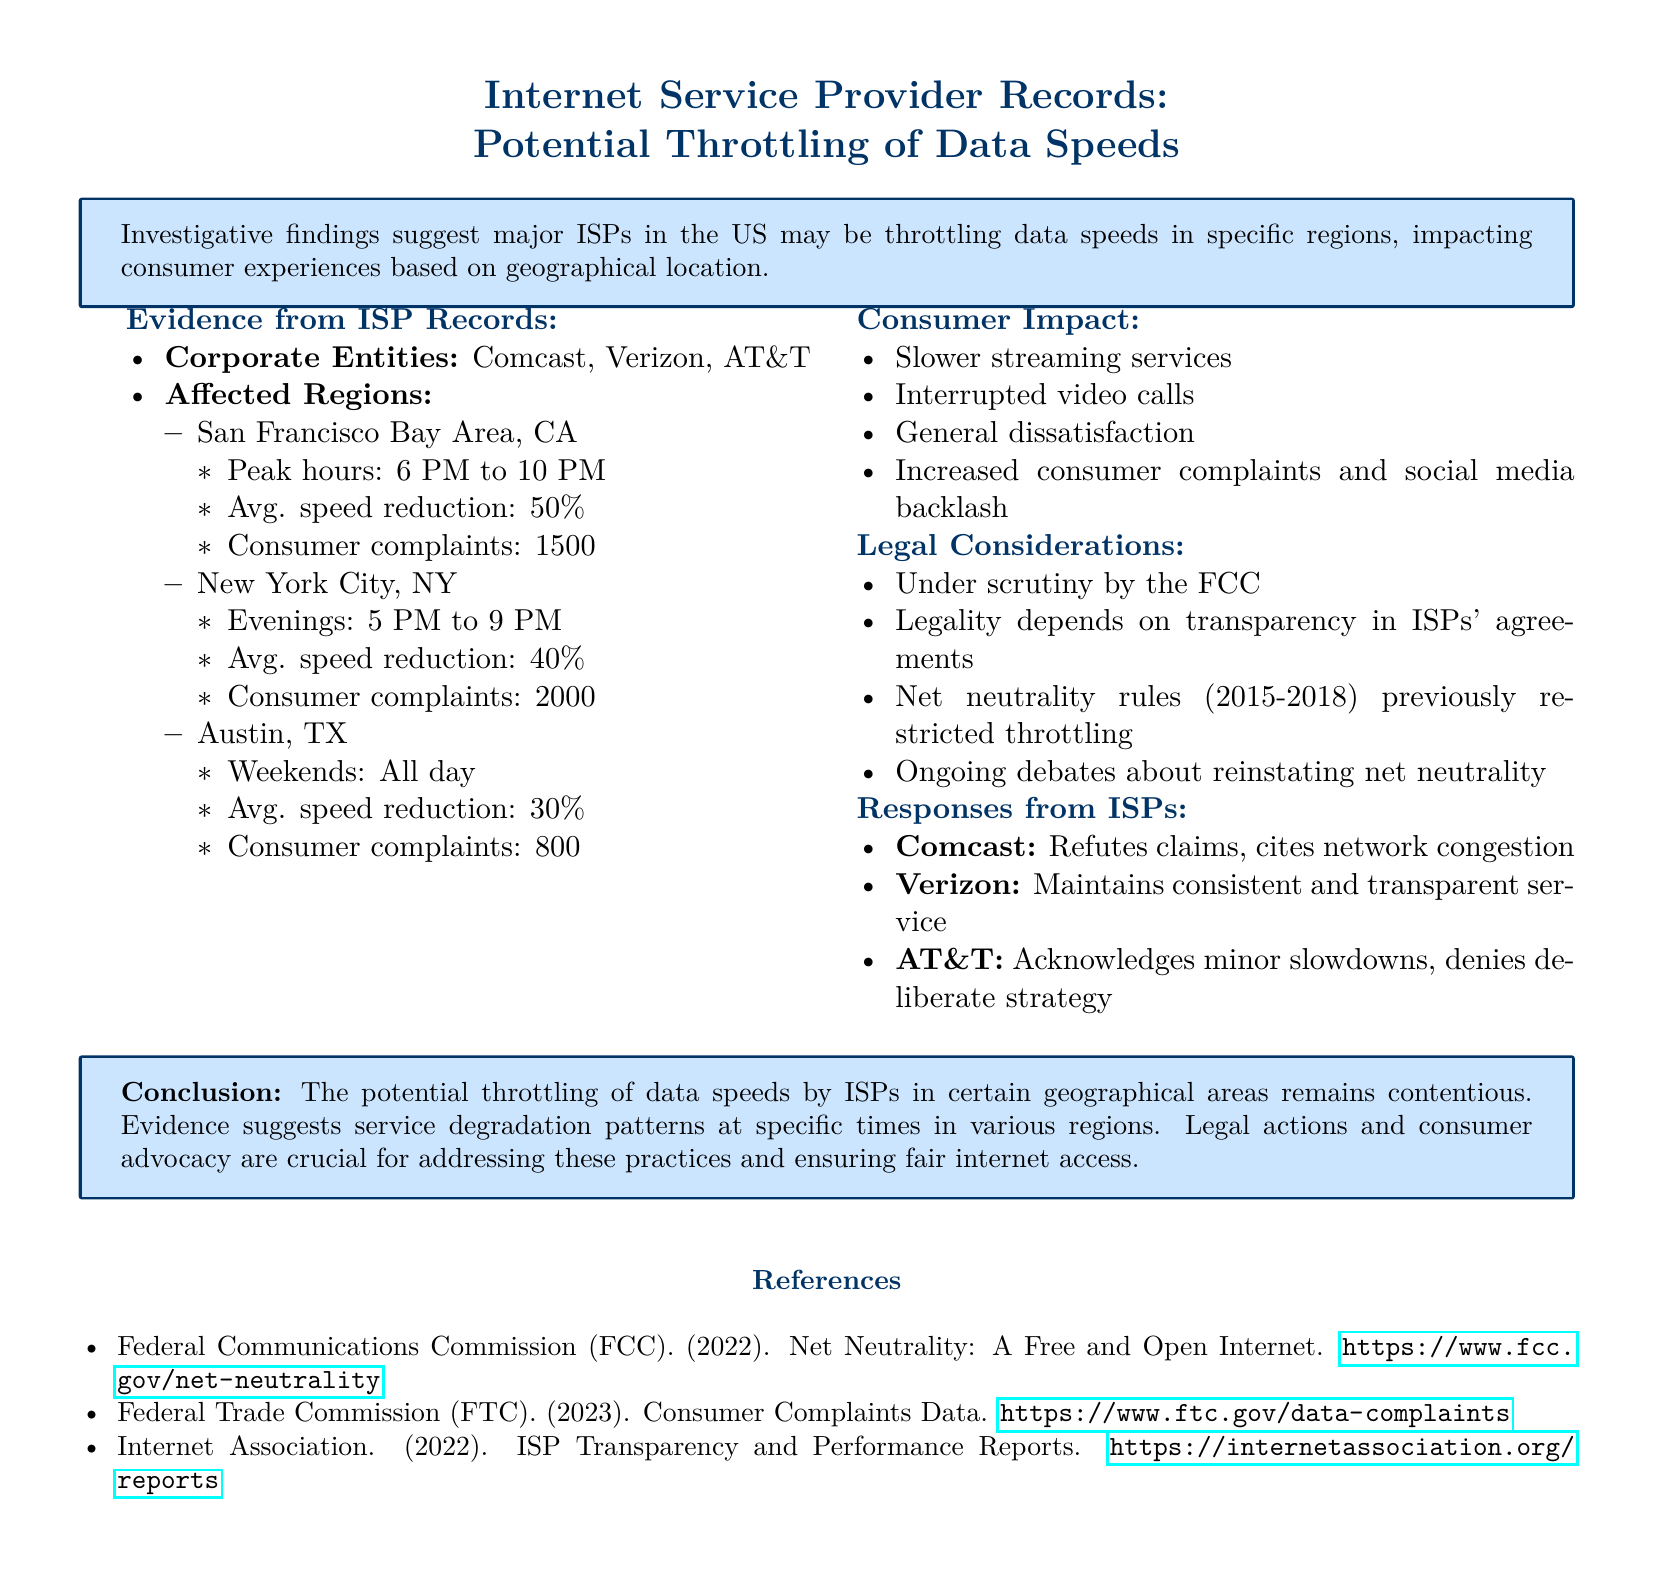What are the major ISPs mentioned? The document lists the major ISPs as Comcast, Verizon, and AT&T.
Answer: Comcast, Verizon, AT&T What is the average speed reduction in New York City during peak hours? In New York City, the average speed reduction during peak hours is reported as 40%.
Answer: 40% How many consumer complaints were recorded in the San Francisco Bay Area? The document states there were 1500 consumer complaints in the San Francisco Bay Area.
Answer: 1500 During which hours is throttling reported in Austin, TX? Throttling in Austin, TX is reported throughout the day on weekends.
Answer: All day What legal body is scrutinizing the ISPs for potential throttling? The Federal Communications Commission (FCC) is mentioned as the body under scrutiny.
Answer: FCC How does AT&T respond to the throttling allegations? AT&T acknowledges minor slowdowns but denies there is a deliberate strategy.
Answer: Acknowledges minor slowdowns What geographical areas are primarily affected by throttling? The affected regions include the San Francisco Bay Area, New York City, and Austin.
Answer: San Francisco Bay Area, New York City, Austin What is the consumer impact associated with slower data speeds? The document lists slower streaming services and interrupted video calls as impacts.
Answer: Slower streaming services, interrupted video calls What is the overall conclusion regarding potential throttling practices? The conclusion highlights that throttling remains contentious with service degradation patterns noted.
Answer: Contentious; service degradation patterns noted 